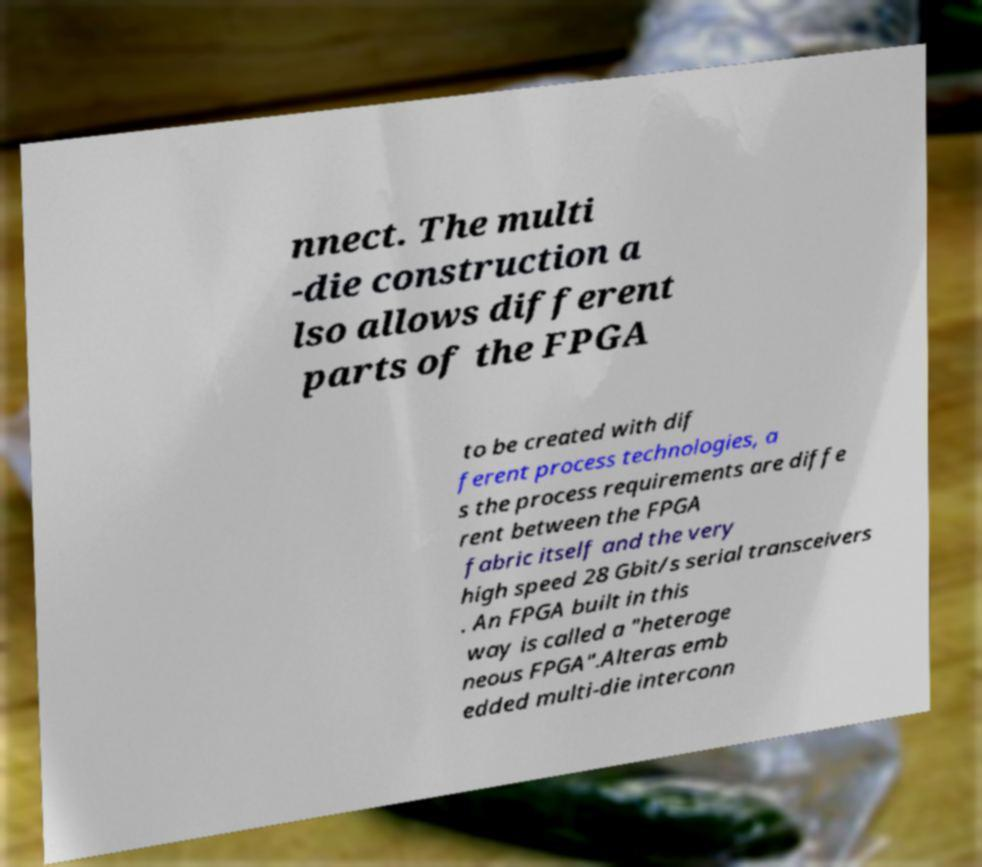There's text embedded in this image that I need extracted. Can you transcribe it verbatim? nnect. The multi -die construction a lso allows different parts of the FPGA to be created with dif ferent process technologies, a s the process requirements are diffe rent between the FPGA fabric itself and the very high speed 28 Gbit/s serial transceivers . An FPGA built in this way is called a "heteroge neous FPGA".Alteras emb edded multi-die interconn 